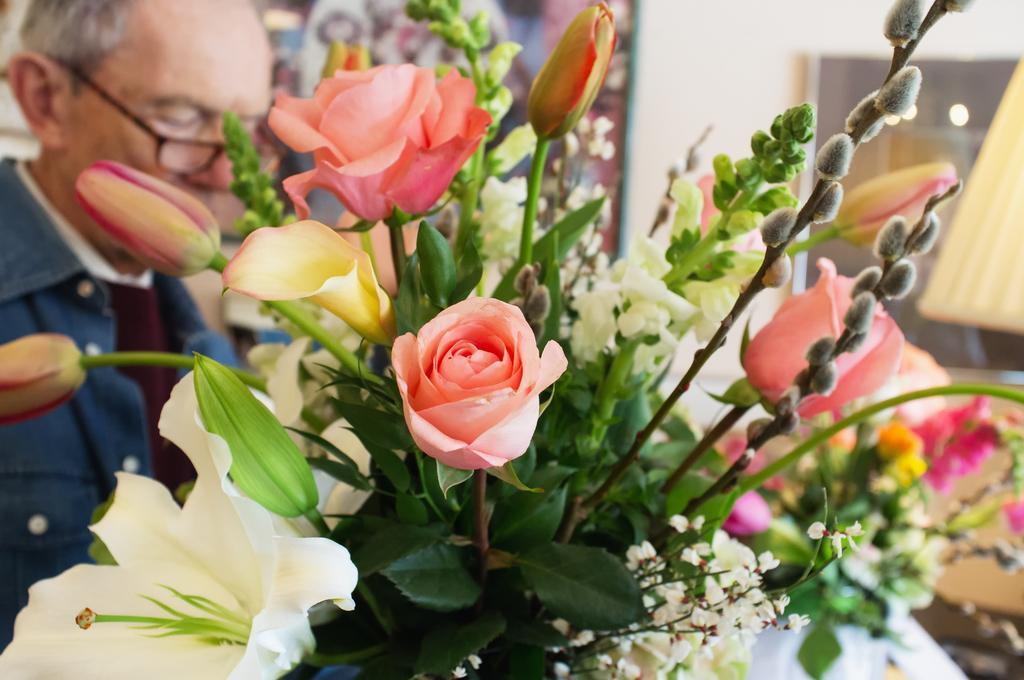What type of plants can be seen in the image? There are flowers and buds in the image. Can you describe the person in the background of the image? The person in the background is wearing glasses. What else can be seen in the image besides the flowers and person? Leaves are visible in the image. What type of sand can be seen in the image? There is no sand present in the image. What message is conveyed by the sign in the image? There is no sign present in the image. 